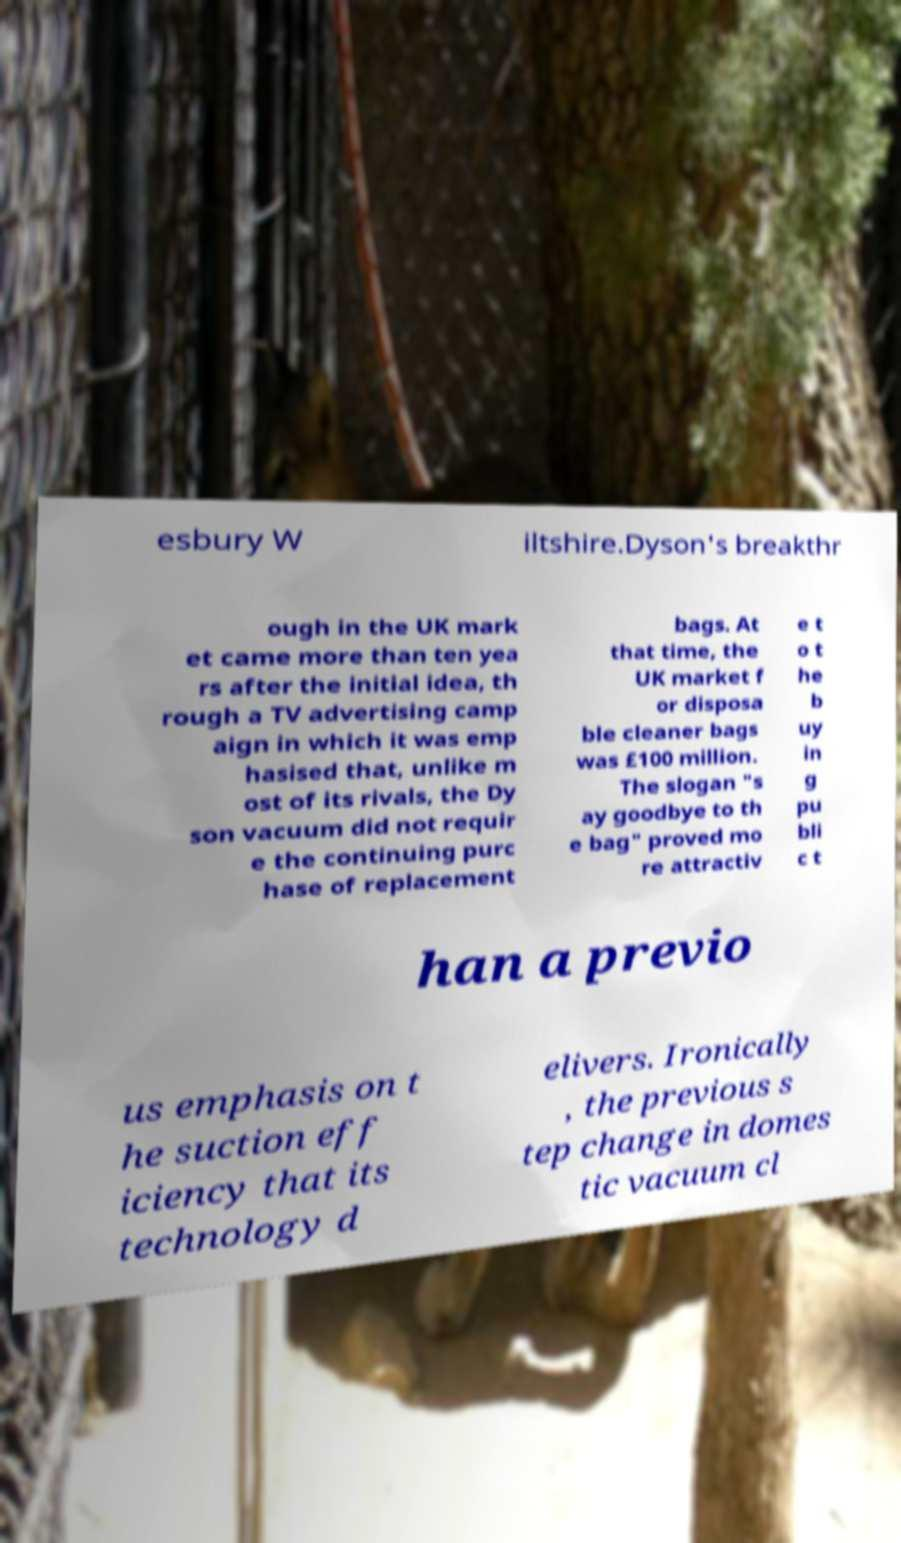Could you assist in decoding the text presented in this image and type it out clearly? esbury W iltshire.Dyson's breakthr ough in the UK mark et came more than ten yea rs after the initial idea, th rough a TV advertising camp aign in which it was emp hasised that, unlike m ost of its rivals, the Dy son vacuum did not requir e the continuing purc hase of replacement bags. At that time, the UK market f or disposa ble cleaner bags was £100 million. The slogan "s ay goodbye to th e bag" proved mo re attractiv e t o t he b uy in g pu bli c t han a previo us emphasis on t he suction eff iciency that its technology d elivers. Ironically , the previous s tep change in domes tic vacuum cl 